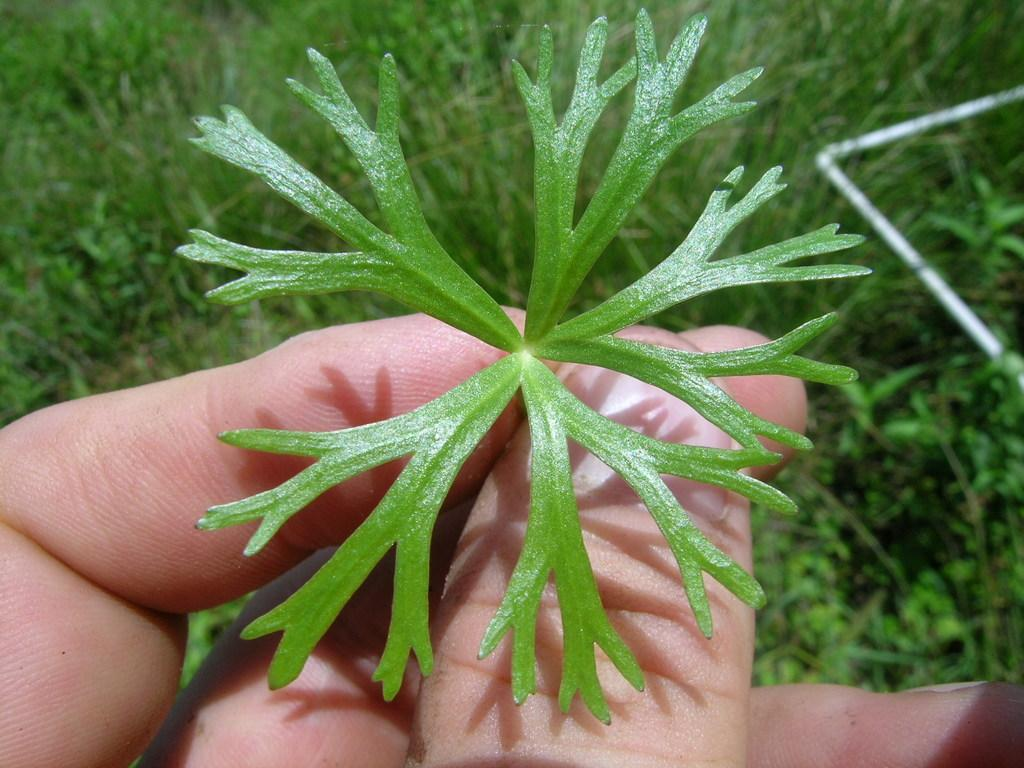Who or what is present in the image? There is a person in the image. What is the person holding in the image? The person is holding a leaf. What can be seen on the right side of the image? There is a pipe on the right side of the image. What type of environment is depicted in the background of the image? There are plants visible in the background of the image. How many cherries are on the kitty's head in the image? There is no kitty or cherries present in the image. 